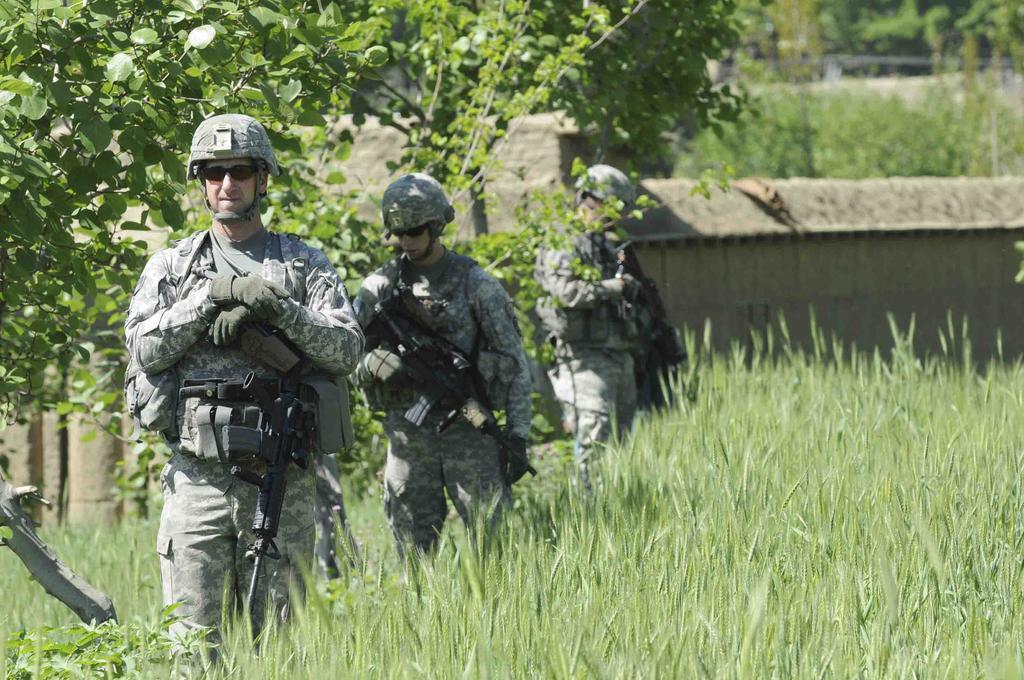In one or two sentences, can you explain what this image depicts? The picture is taken in a field. In the foreground of the picture there are two army soldiers and there are plants and trees. The background is blurred. In the background there are trees, wall, soldier and grass. Sky is sunny. 